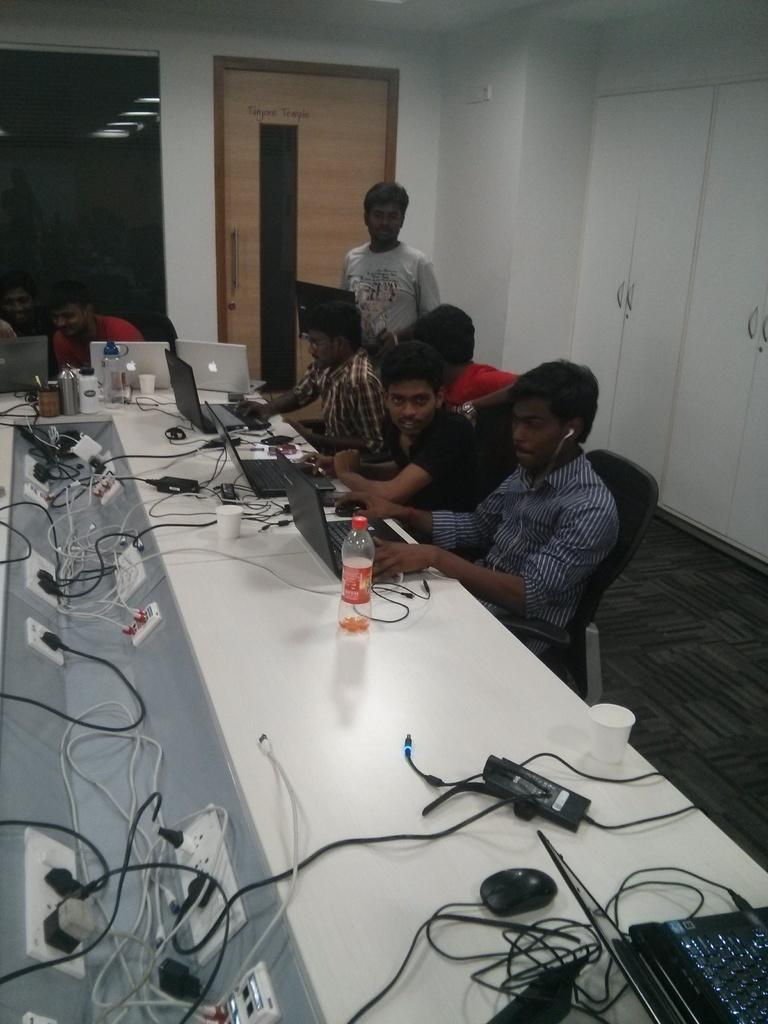What type of structure can be seen in the image? There is a wall in the image. What feature is present in the wall? There is a door in the image. What are the people in the image doing? The people are sitting on chairs in the image. What is on the table in the image? There is a table in the image with laptops, mouse devices, wires, a bottle, and glasses on it. What type of army is visible in the image? There is no army present in the image. How much payment is being made in the image? There is no payment being made in the image. 